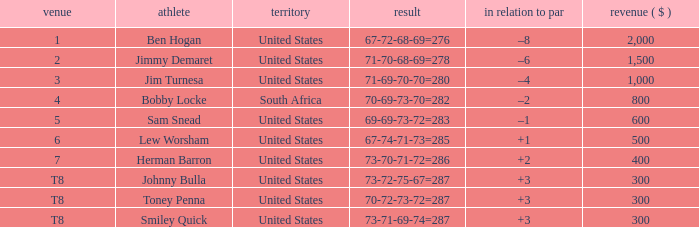What is the Place of the Player with Money greater than 300 and a Score of 71-69-70-70=280? 3.0. 